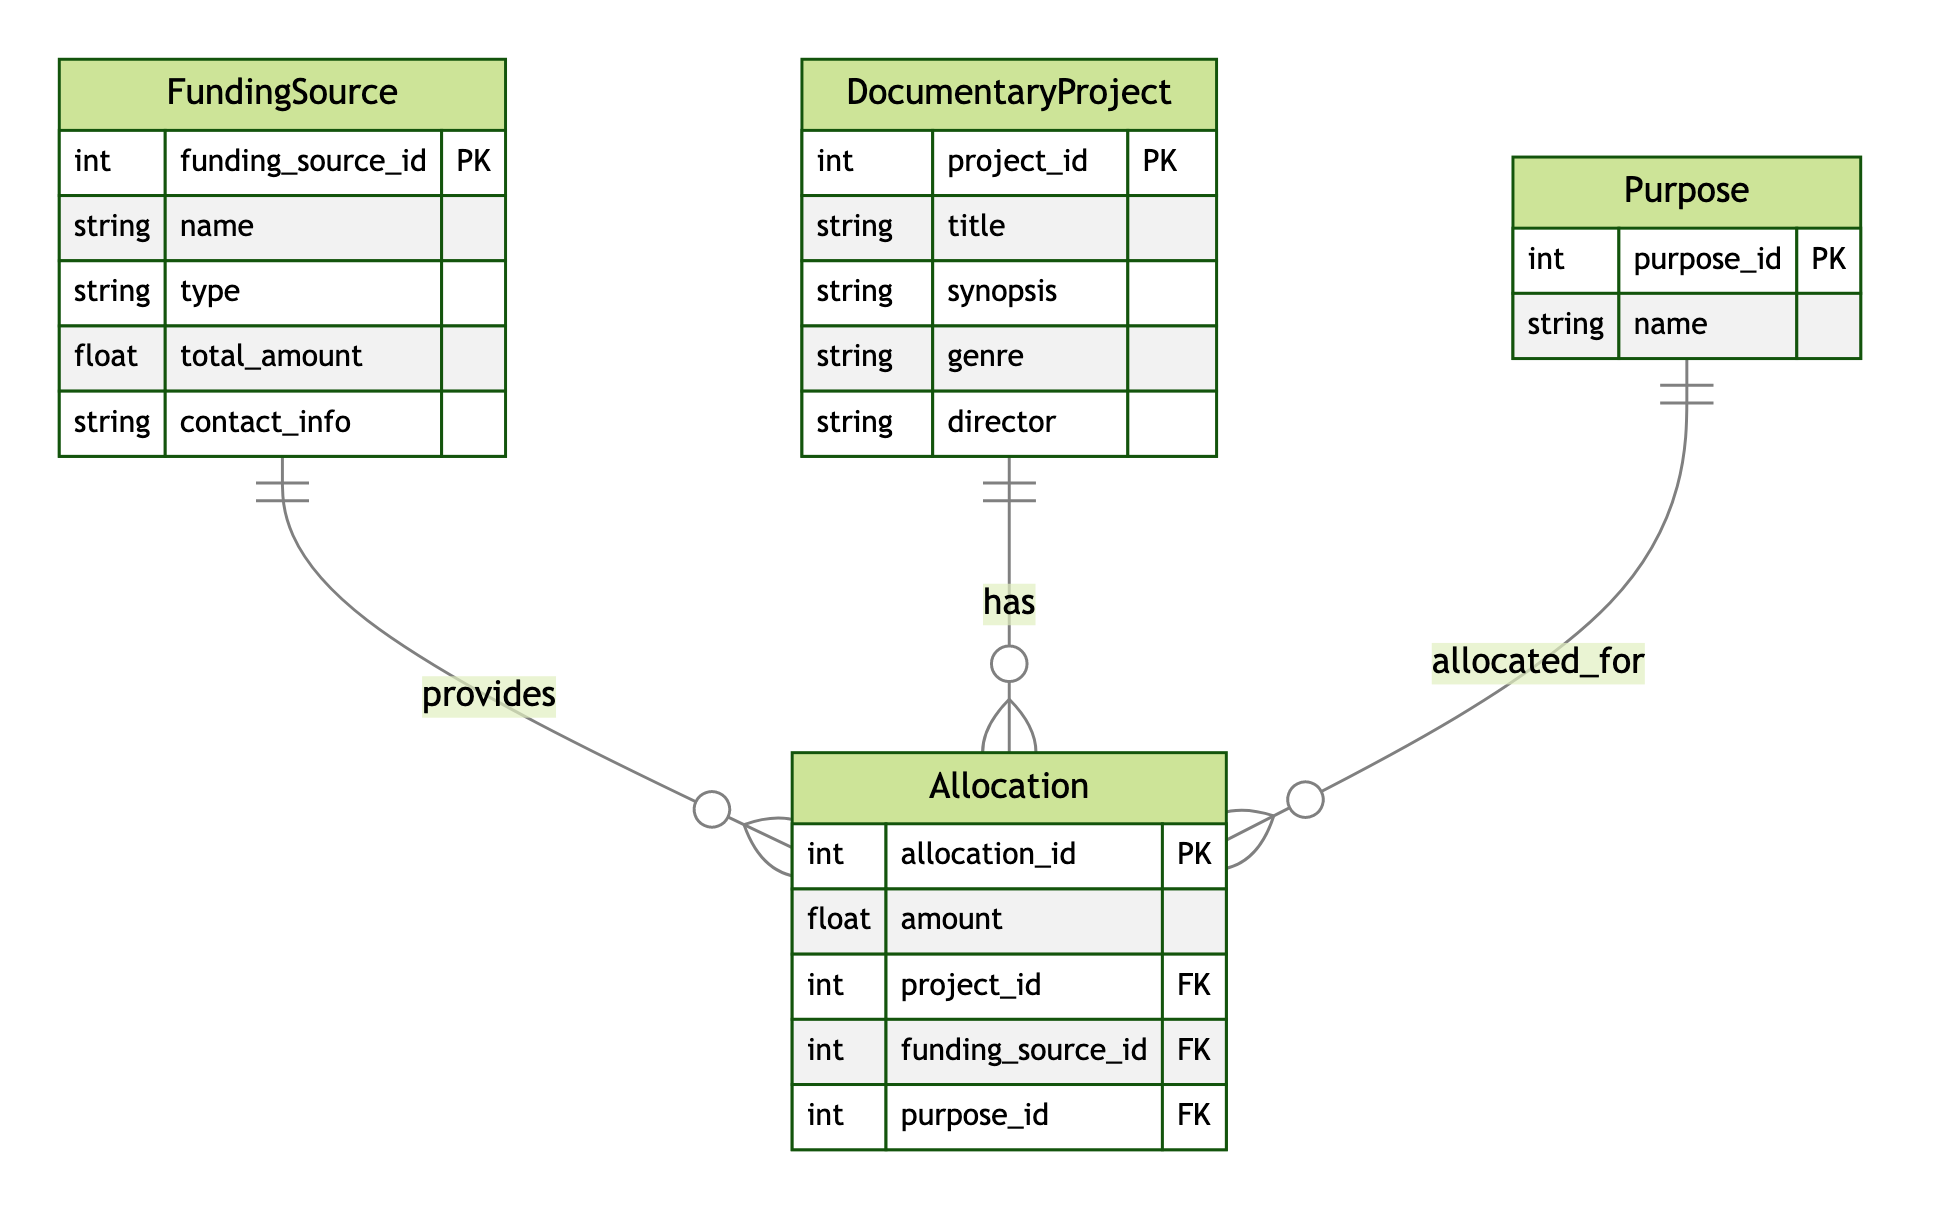what is the primary entity representing funding sources? The diagram identifies "FundingSource" as the primary entity representing funding sources, which includes attributes such as funding source ID, name, type, total amount, and contact info.
Answer: FundingSource how many entities are represented in this diagram? The diagram lists four distinct entities: FundingSource, DocumentaryProject, Allocation, and Purpose. Counting these reveals the total number of entities represented.
Answer: 4 which entity is associated with project allocations? The relationship diagrams show that "DocumentaryProject" has a one-to-many relationship with "Allocation," indicating that allocations are connected to specific documentary projects.
Answer: DocumentaryProject what type of relationship exists between FundingSource and DocumentaryProject? The diagram specifies that the relationship between FundingSource and DocumentaryProject is many-to-many, indicating that multiple funding sources can fund multiple documentary projects.
Answer: many-to-many how many attributes does the Allocation entity have? By examining the Allocation entity in the diagram, it can be seen that it has four attributes: allocation ID, amount, project ID, and funding source ID. Counting these provides the total count of attributes.
Answer: 4 which entity contains the purpose information related to allocations? The diagram indicates that the entity "Purpose" holds information about the purposes for which funds are allocated, as shown by its relationship to the Allocation entity.
Answer: Purpose how many relationships are defined in this diagram? The diagram consists of three defined relationships: FundingSource provides funding to DocumentaryProject, DocumentaryProject has allocations, and Purpose is allocated for Allocation. Counting these gives the total number of relationships.
Answer: 3 what is the foreign key in the Allocation entity that connects to the Purpose entity? The diagram identifies the foreign key in the Allocation entity that links it to the Purpose entity as purpose ID. This attribute connects the allocation details with the specific purpose.
Answer: purpose_id which entity is identified as having direct associations with both FundingSource and Allocation? Since DocumentaryProject has allocations and receives funding from multiple FundingSources, it serves as the connecting entity between both FundingSource and Allocation.
Answer: DocumentaryProject 